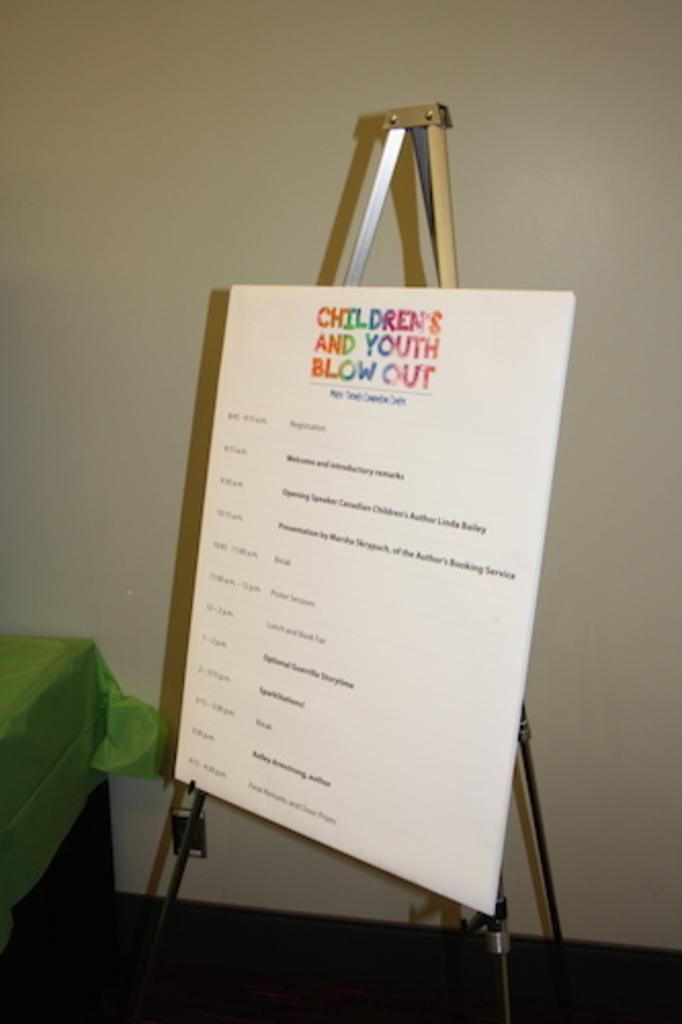What event is being shown?
Provide a succinct answer. Children's and youth blow out. 